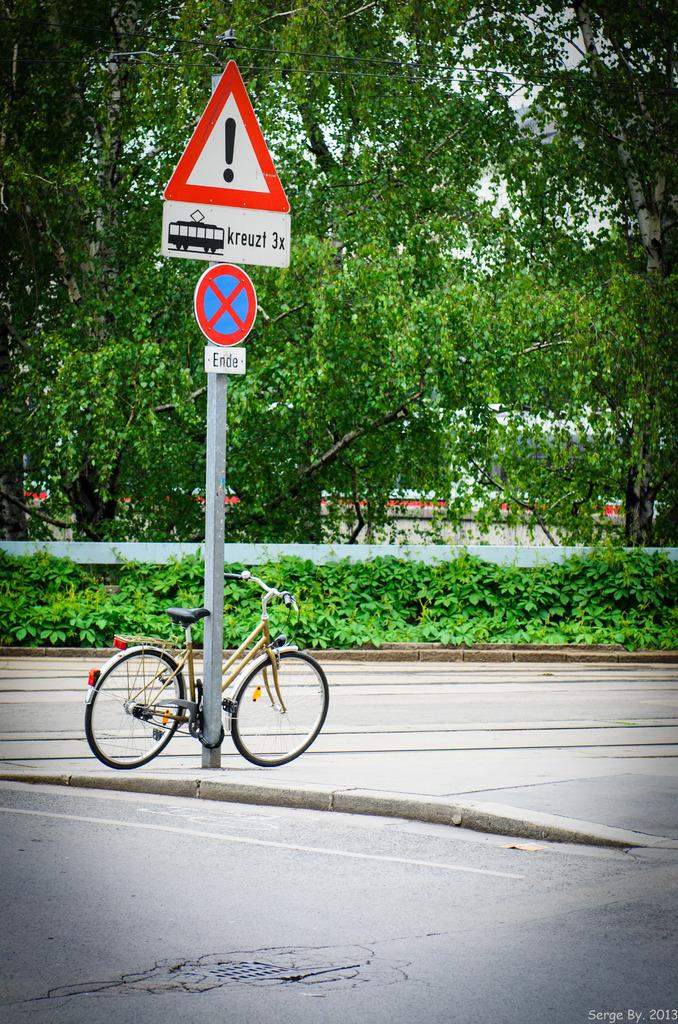What common punctuation symbol is found in large font on this sign?
Provide a succinct answer. !. What does the bottom sign mean?
Your response must be concise. Unanswerable. 